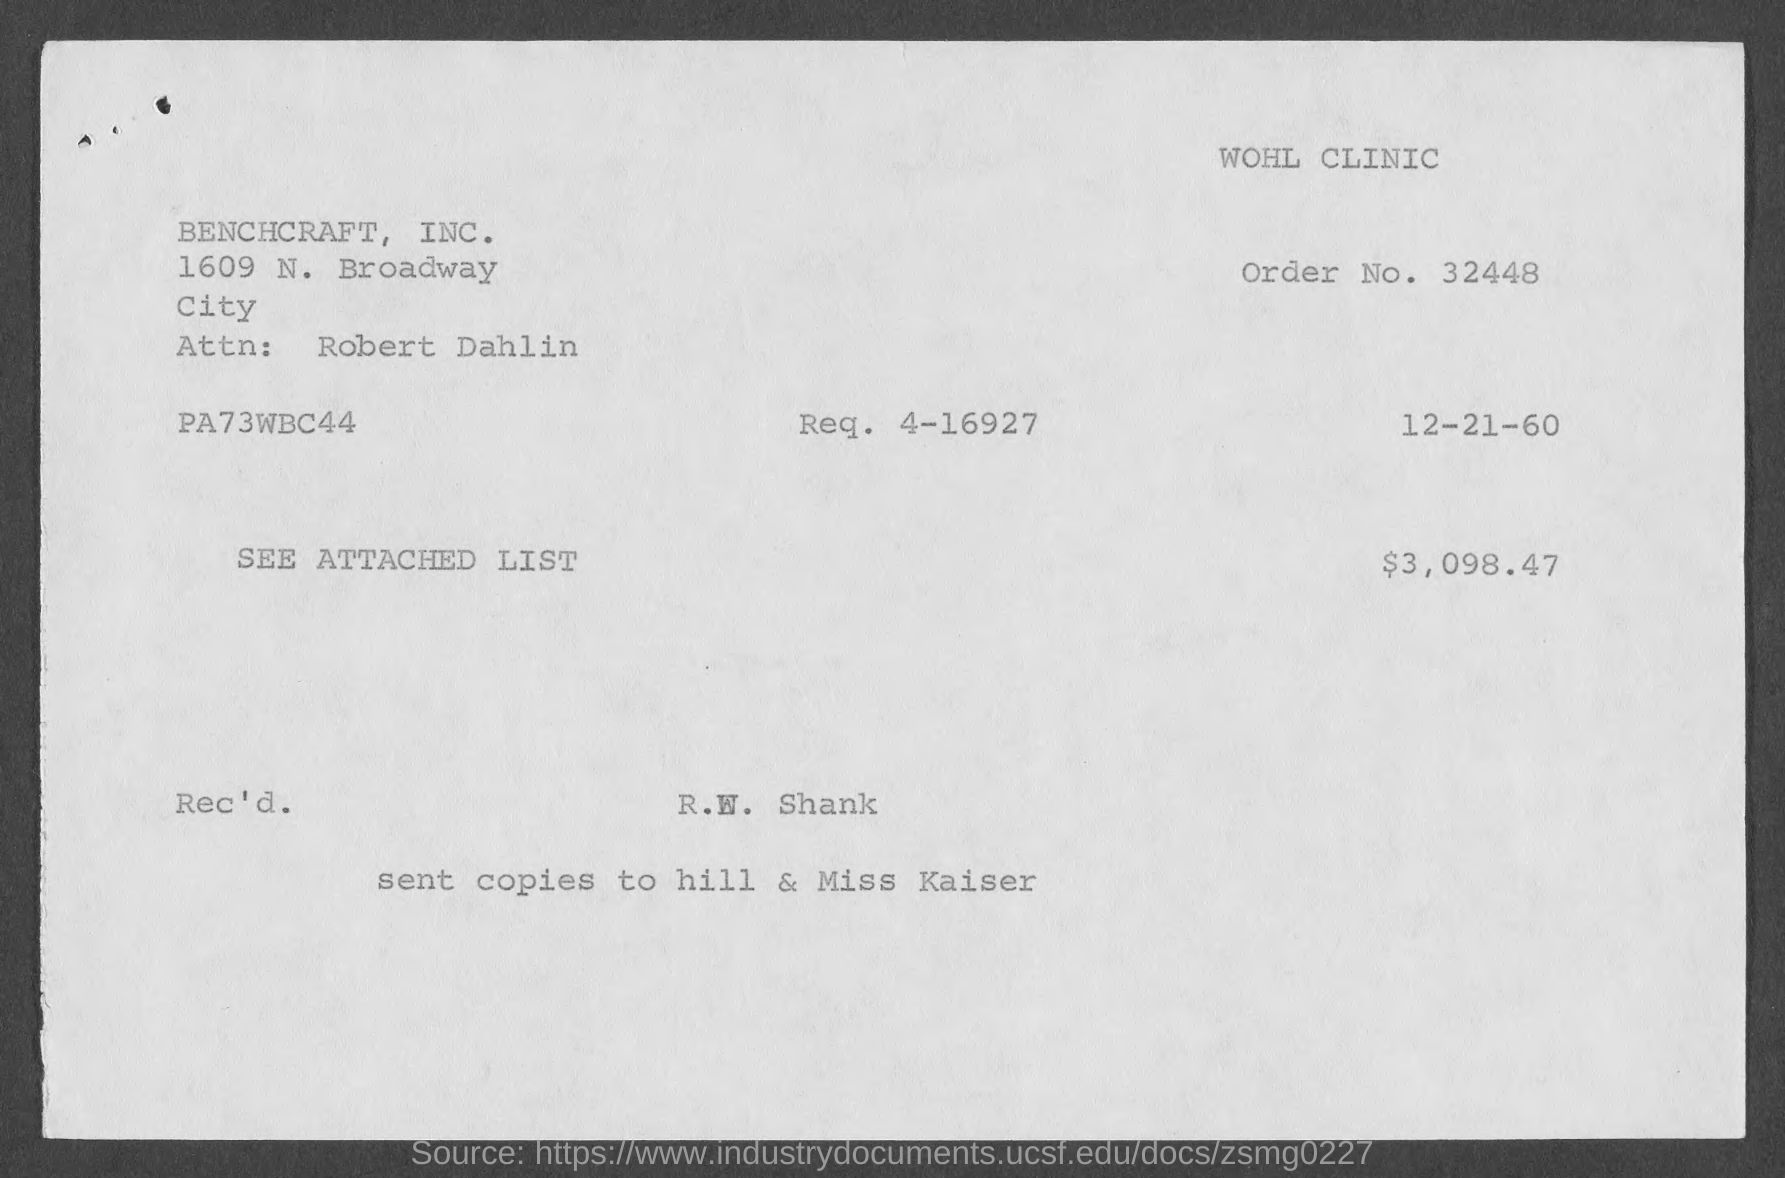Identify some key points in this picture. The order number is 32448... The document indicates that the date is December 21, 1960. The attention of Robert Dahlin is requested. 